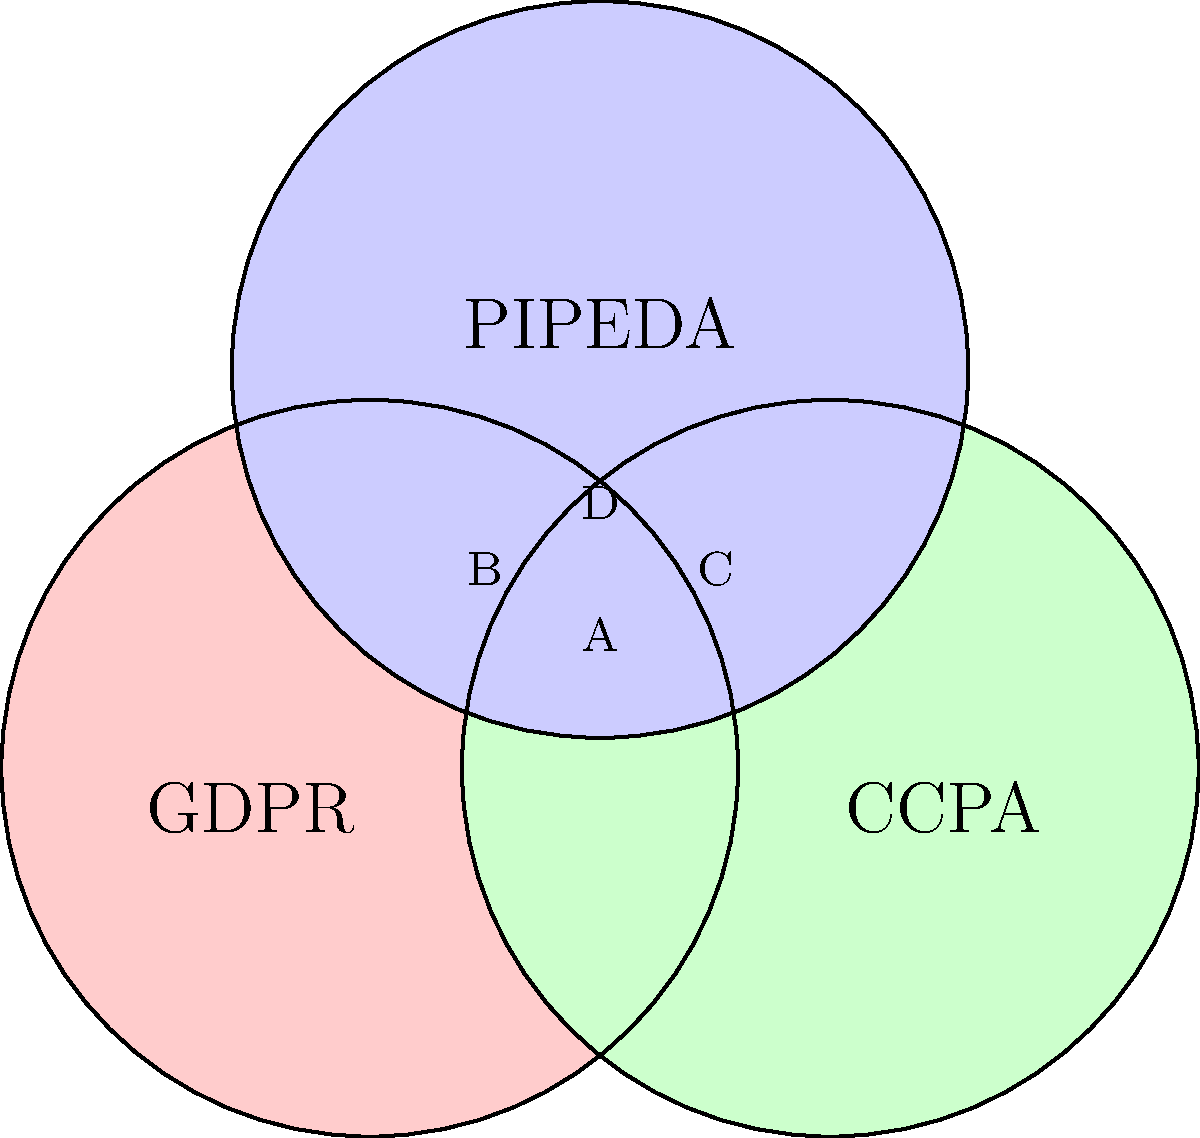The Venn diagram above illustrates the overlapping areas of three major data protection regulations: GDPR (EU), CCPA (California), and PIPEDA (Canada). As a corporate lawyer representing a tech company, which area in the diagram would represent the most comprehensive compliance requirements, covering all three regulations simultaneously? To answer this question, we need to analyze the Venn diagram and understand the overlapping areas:

1. The diagram shows three circles representing GDPR, CCPA, and PIPEDA.
2. Each circle overlaps with the other two, creating seven distinct regions.
3. The regions are:
   - Three areas where only one regulation applies (the outer parts of each circle)
   - Three areas where two regulations overlap (labeled A, B, and C)
   - One area where all three regulations overlap (labeled D)

4. The question asks for the area that represents compliance with all three regulations simultaneously.
5. This would be the region where all three circles intersect, which is the central area labeled D.

6. Area D represents the most comprehensive compliance requirements because:
   - It includes requirements from GDPR, CCPA, and PIPEDA
   - Any company complying with the regulations in this area would be adhering to the strictest standards from all three regulatory frameworks

7. As a corporate lawyer, understanding this area is crucial because:
   - It represents the highest level of data protection compliance
   - Adhering to these standards would likely ensure compliance across all three jurisdictions
   - It may be the most efficient approach for a tech company operating internationally

Therefore, the area that represents the most comprehensive compliance requirements, covering all three regulations simultaneously, is the central region D.
Answer: D 